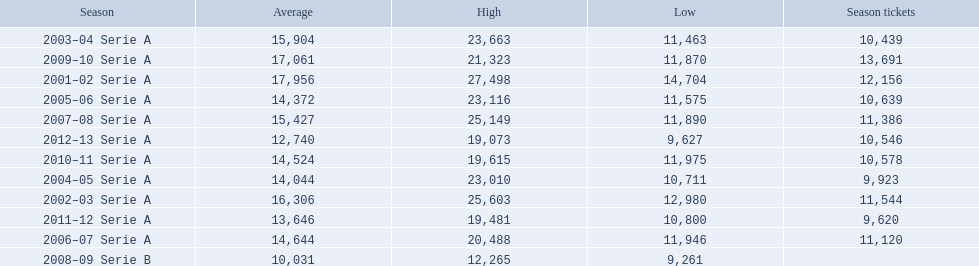When were all of the seasons? 2001–02 Serie A, 2002–03 Serie A, 2003–04 Serie A, 2004–05 Serie A, 2005–06 Serie A, 2006–07 Serie A, 2007–08 Serie A, 2008–09 Serie B, 2009–10 Serie A, 2010–11 Serie A, 2011–12 Serie A, 2012–13 Serie A. How many tickets were sold? 12,156, 11,544, 10,439, 9,923, 10,639, 11,120, 11,386, , 13,691, 10,578, 9,620, 10,546. What about just during the 2007 season? 11,386. 